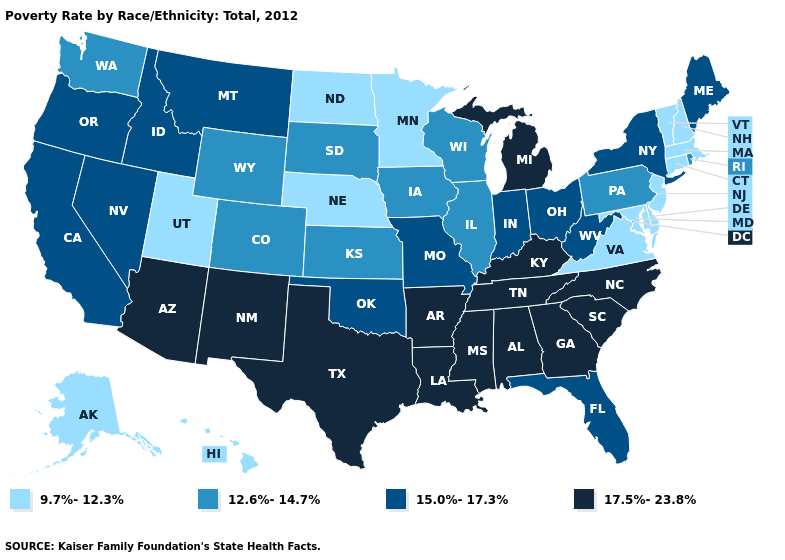Which states have the lowest value in the USA?
Keep it brief. Alaska, Connecticut, Delaware, Hawaii, Maryland, Massachusetts, Minnesota, Nebraska, New Hampshire, New Jersey, North Dakota, Utah, Vermont, Virginia. Does Texas have a higher value than Wyoming?
Write a very short answer. Yes. Does the map have missing data?
Give a very brief answer. No. What is the lowest value in the USA?
Short answer required. 9.7%-12.3%. What is the value of New Jersey?
Quick response, please. 9.7%-12.3%. What is the value of Indiana?
Write a very short answer. 15.0%-17.3%. What is the value of New Hampshire?
Concise answer only. 9.7%-12.3%. Does the first symbol in the legend represent the smallest category?
Keep it brief. Yes. Name the states that have a value in the range 9.7%-12.3%?
Quick response, please. Alaska, Connecticut, Delaware, Hawaii, Maryland, Massachusetts, Minnesota, Nebraska, New Hampshire, New Jersey, North Dakota, Utah, Vermont, Virginia. What is the highest value in the USA?
Concise answer only. 17.5%-23.8%. Name the states that have a value in the range 12.6%-14.7%?
Concise answer only. Colorado, Illinois, Iowa, Kansas, Pennsylvania, Rhode Island, South Dakota, Washington, Wisconsin, Wyoming. Does the map have missing data?
Be succinct. No. Name the states that have a value in the range 15.0%-17.3%?
Short answer required. California, Florida, Idaho, Indiana, Maine, Missouri, Montana, Nevada, New York, Ohio, Oklahoma, Oregon, West Virginia. Which states have the highest value in the USA?
Give a very brief answer. Alabama, Arizona, Arkansas, Georgia, Kentucky, Louisiana, Michigan, Mississippi, New Mexico, North Carolina, South Carolina, Tennessee, Texas. What is the value of Iowa?
Write a very short answer. 12.6%-14.7%. 